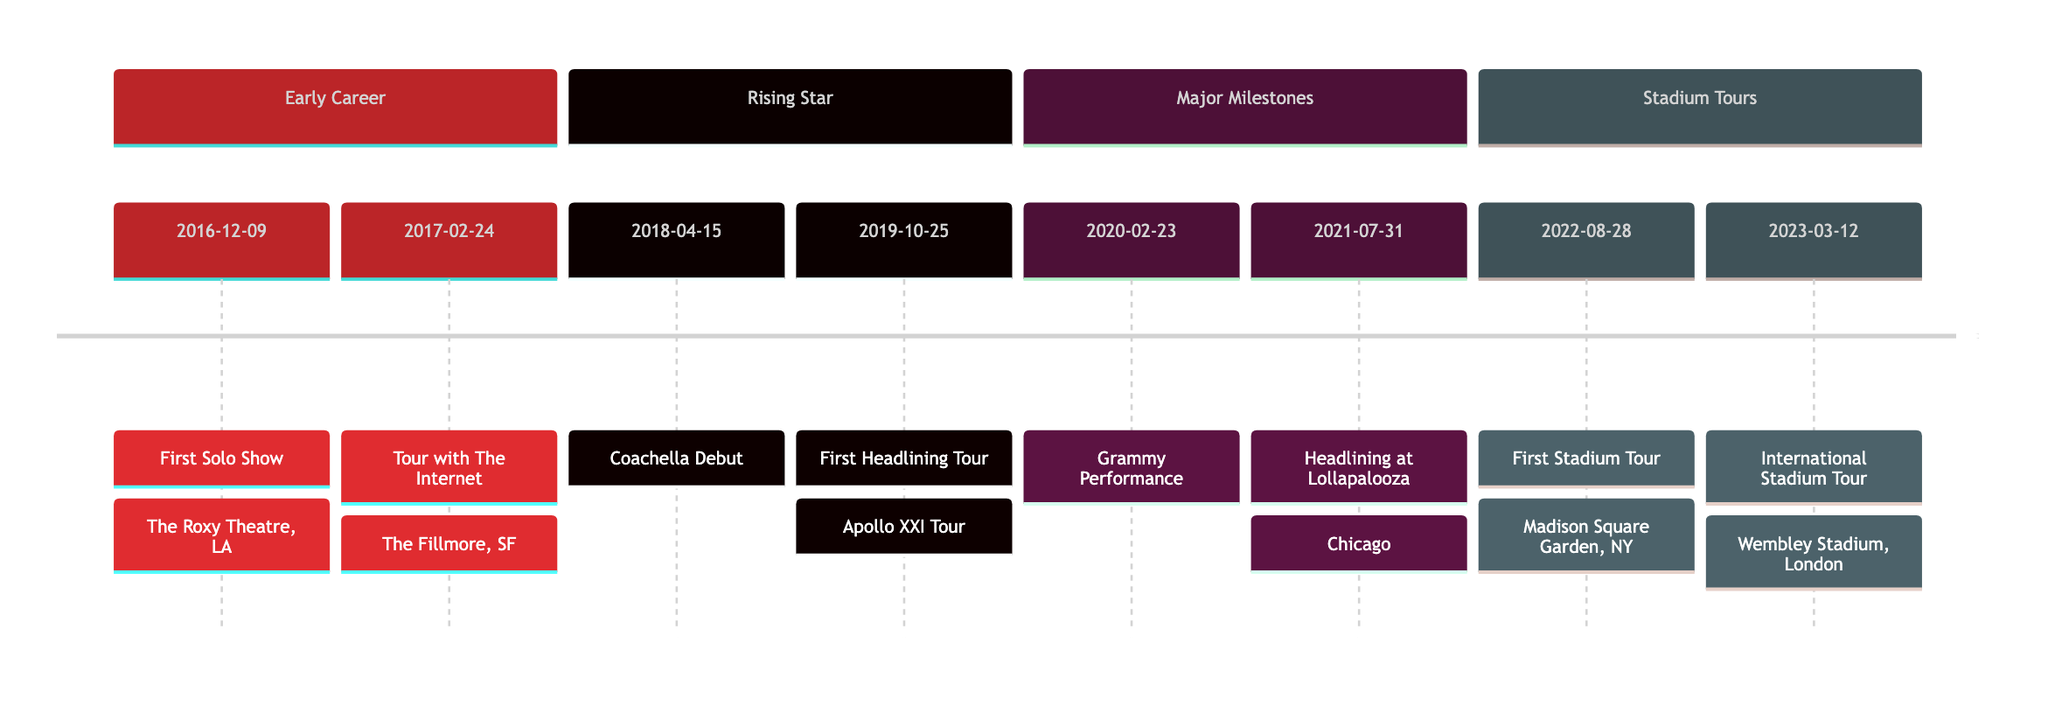What was Steve Lacy's first solo show? The information presented in the diagram indicates that Steve Lacy's first solo show took place on December 9, 2016, and it was held at The Roxy Theatre in Los Angeles. This is the first entry in the "Early Career" section.
Answer: First Solo Show When did Steve Lacy join The Internet on tour? According to the timeline, Steve Lacy joined The Internet on their tour on February 24, 2017. This date is listed right after his first solo show.
Answer: 2017-02-24 What significant performance did Steve Lacy have in 2020? The diagram shows that in 2020, Steve Lacy had a performance at the Grammy Awards on February 23. This is captured under the "Major Milestones" section.
Answer: Grammy Performance Which festival did Steve Lacy headline in 2021? The information states that on July 31, 2021, Steve Lacy headlined at Lollapalooza in Chicago. This event is noted in the "Major Milestones" section of the timeline.
Answer: Lollapalooza What year did Steve Lacy begin his first stadium tour? The timeline clearly shows that Steve Lacy kicked off his first stadium tour on August 28, 2022. This date is listed in the "Stadium Tours" section.
Answer: 2022-08-28 How many major tours are mentioned in the timeline? The diagram lists a total of four major tours: the tour with The Internet, the Apollo XXI Tour, the Lollapalooza performance, and the stadium tour. Therefore, by counting these significant events, we can conclude there are four major tours mentioned.
Answer: 4 In which city did Steve Lacy have his first headlining tour? The first headlining tour, known as the Apollo XXI Tour, began at The Academy in Dublin, which is detailed in the timeline. Thus, the city where this event took place is Dublin.
Answer: Dublin What is the last event listed on the timeline? By reviewing the diagram, the last event documented is the international stadium tour, which started on March 12, 2023, at Wembley Stadium in London. This is the final entry under the "Stadium Tours" section.
Answer: International Stadium Tour What major venue did Steve Lacy perform at for his stadium tour? The diagram indicates that Steve Lacy's first stadium tour commenced at Madison Square Garden in New York, which is specifically highlighted in the timeline.
Answer: Madison Square Garden 